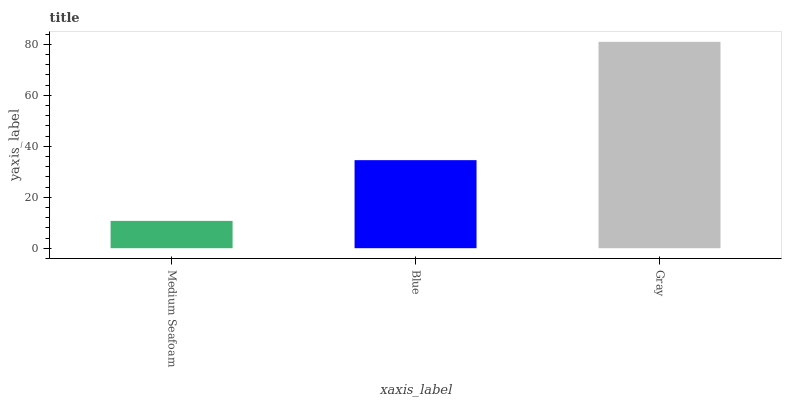Is Blue the minimum?
Answer yes or no. No. Is Blue the maximum?
Answer yes or no. No. Is Blue greater than Medium Seafoam?
Answer yes or no. Yes. Is Medium Seafoam less than Blue?
Answer yes or no. Yes. Is Medium Seafoam greater than Blue?
Answer yes or no. No. Is Blue less than Medium Seafoam?
Answer yes or no. No. Is Blue the high median?
Answer yes or no. Yes. Is Blue the low median?
Answer yes or no. Yes. Is Gray the high median?
Answer yes or no. No. Is Medium Seafoam the low median?
Answer yes or no. No. 